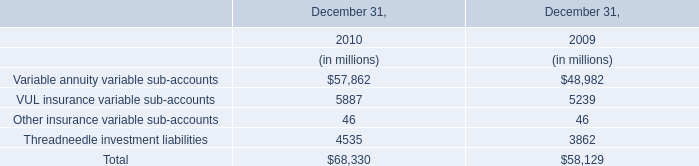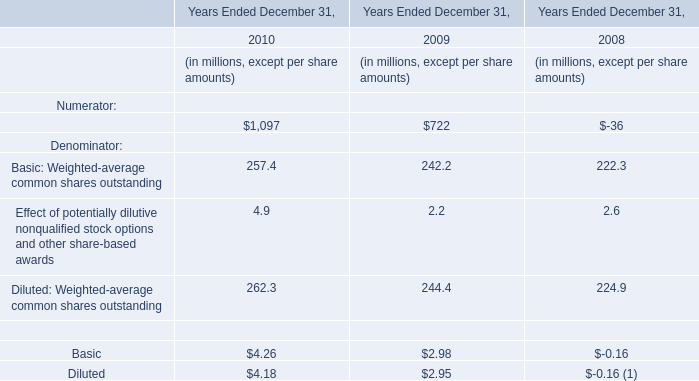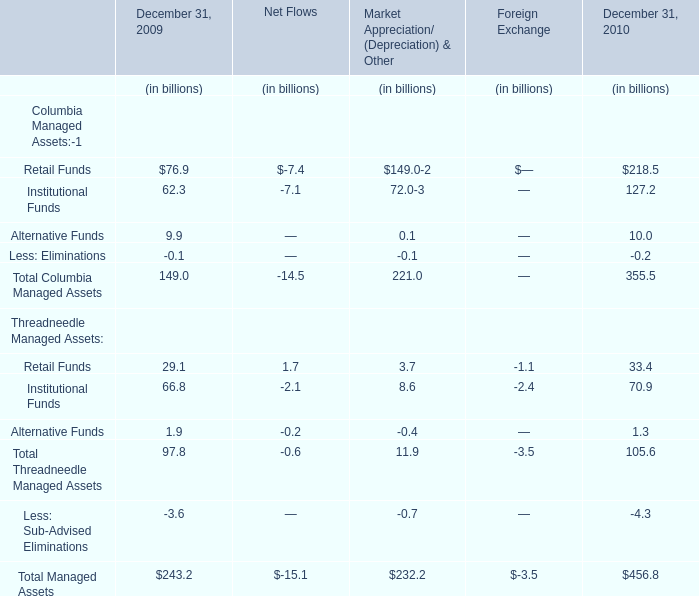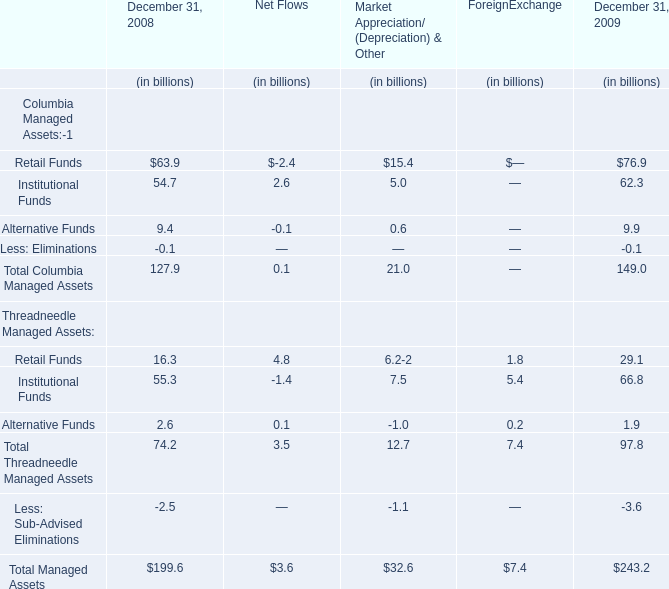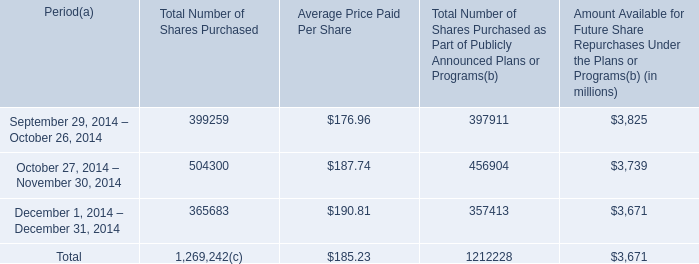What is the ratio of Total Columbia Managed Assets to Total Managed Assets in 2008 as December 31, 2008? 
Computations: (127.9 / 199.6)
Answer: 0.64078. 